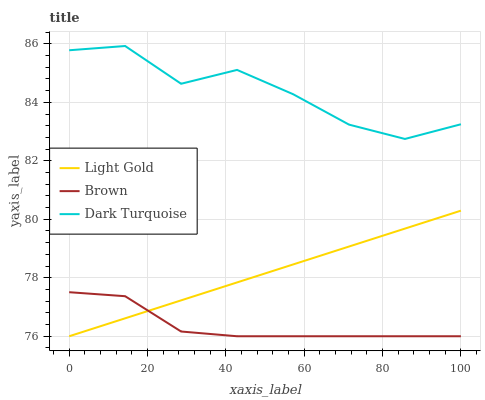Does Brown have the minimum area under the curve?
Answer yes or no. Yes. Does Dark Turquoise have the maximum area under the curve?
Answer yes or no. Yes. Does Light Gold have the minimum area under the curve?
Answer yes or no. No. Does Light Gold have the maximum area under the curve?
Answer yes or no. No. Is Light Gold the smoothest?
Answer yes or no. Yes. Is Dark Turquoise the roughest?
Answer yes or no. Yes. Is Dark Turquoise the smoothest?
Answer yes or no. No. Is Light Gold the roughest?
Answer yes or no. No. Does Brown have the lowest value?
Answer yes or no. Yes. Does Dark Turquoise have the lowest value?
Answer yes or no. No. Does Dark Turquoise have the highest value?
Answer yes or no. Yes. Does Light Gold have the highest value?
Answer yes or no. No. Is Brown less than Dark Turquoise?
Answer yes or no. Yes. Is Dark Turquoise greater than Brown?
Answer yes or no. Yes. Does Brown intersect Light Gold?
Answer yes or no. Yes. Is Brown less than Light Gold?
Answer yes or no. No. Is Brown greater than Light Gold?
Answer yes or no. No. Does Brown intersect Dark Turquoise?
Answer yes or no. No. 